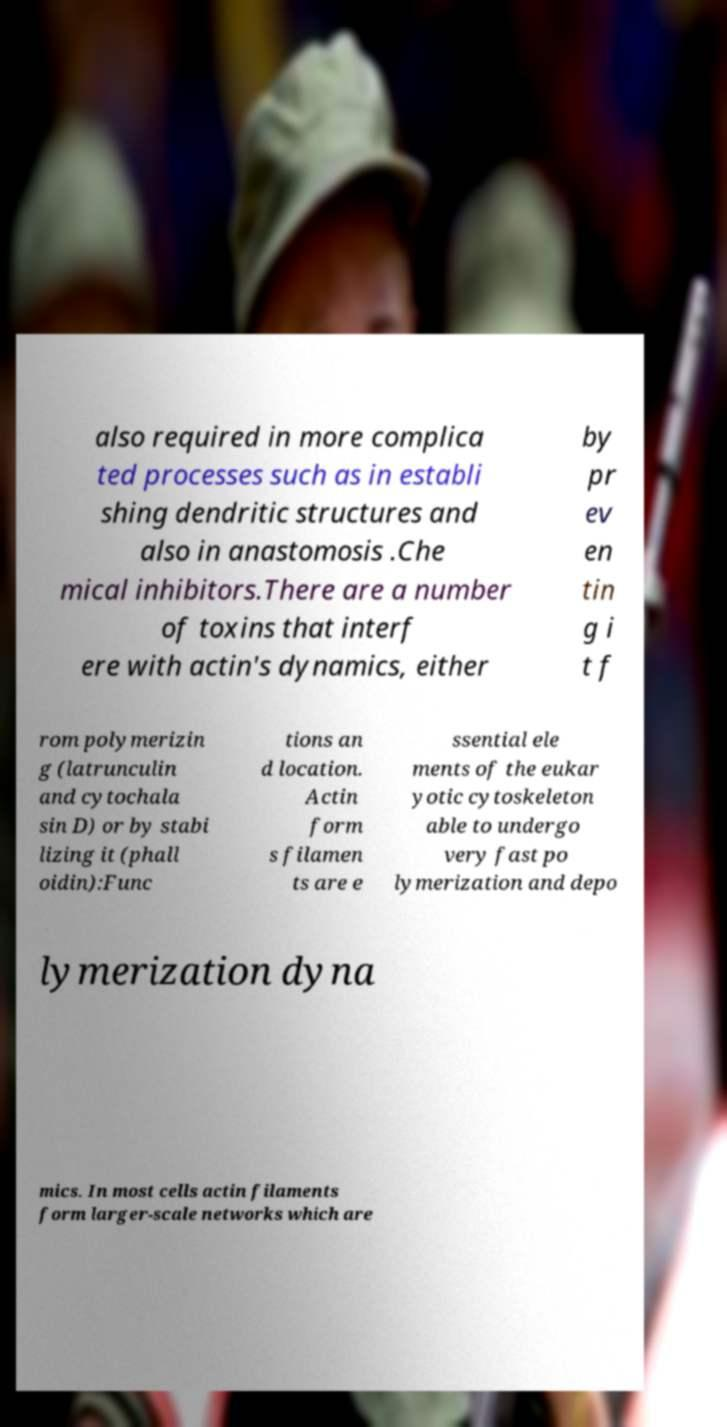Can you read and provide the text displayed in the image?This photo seems to have some interesting text. Can you extract and type it out for me? also required in more complica ted processes such as in establi shing dendritic structures and also in anastomosis .Che mical inhibitors.There are a number of toxins that interf ere with actin's dynamics, either by pr ev en tin g i t f rom polymerizin g (latrunculin and cytochala sin D) or by stabi lizing it (phall oidin):Func tions an d location. Actin form s filamen ts are e ssential ele ments of the eukar yotic cytoskeleton able to undergo very fast po lymerization and depo lymerization dyna mics. In most cells actin filaments form larger-scale networks which are 